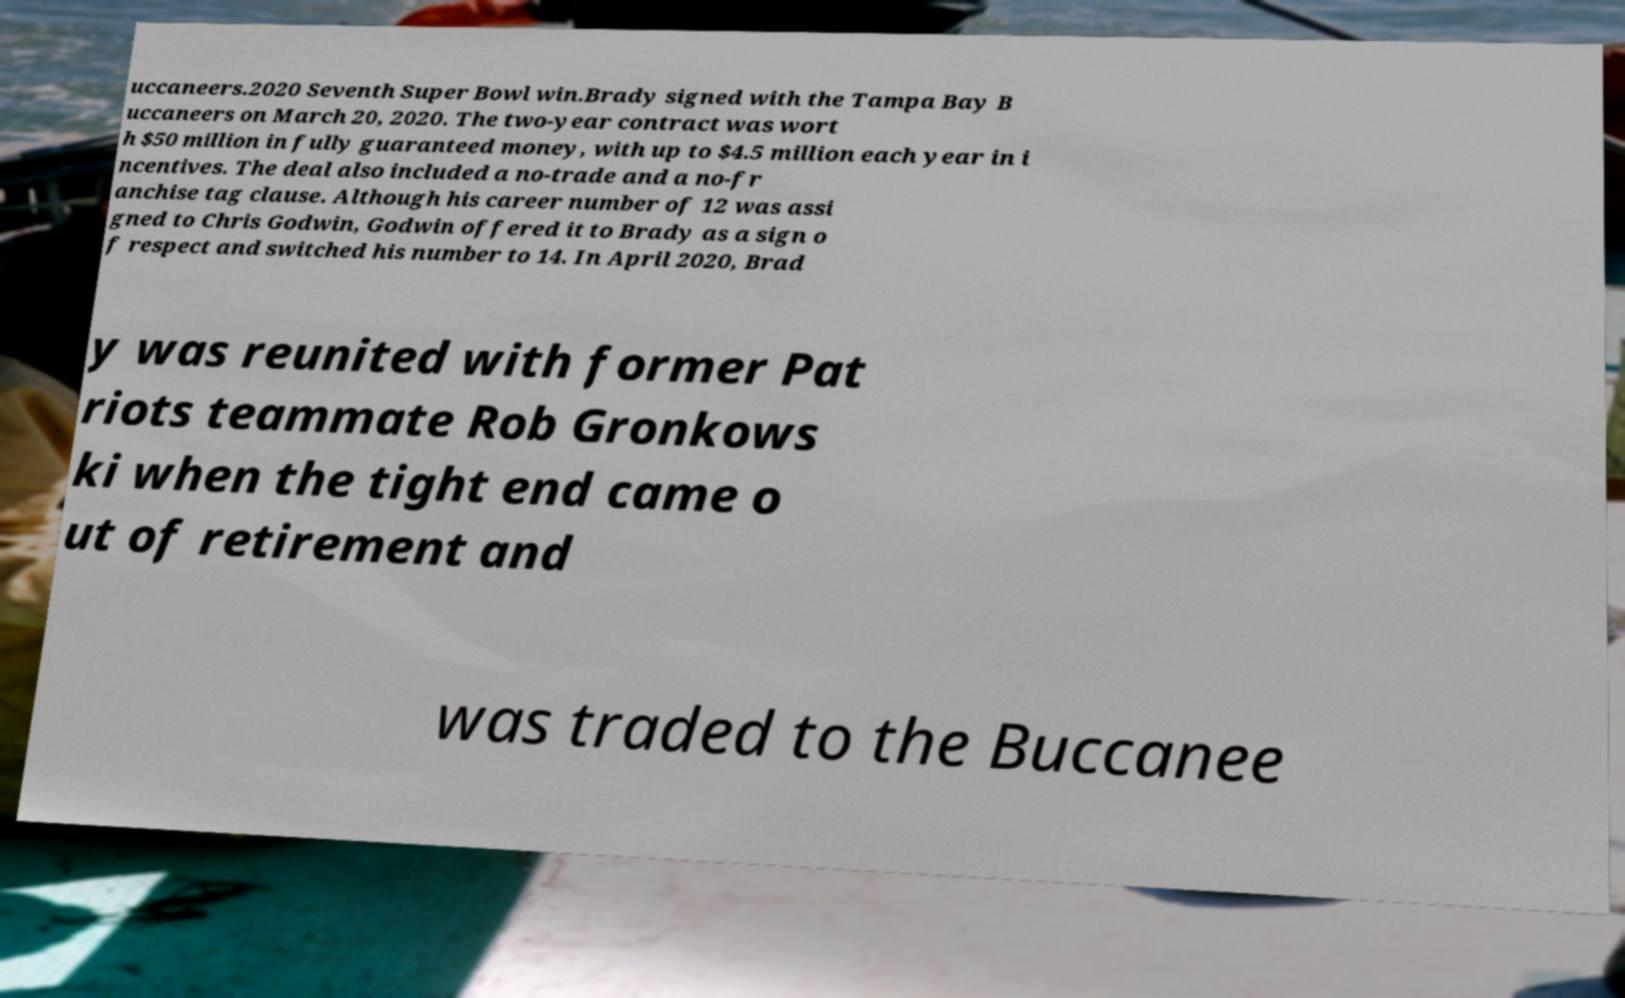There's text embedded in this image that I need extracted. Can you transcribe it verbatim? uccaneers.2020 Seventh Super Bowl win.Brady signed with the Tampa Bay B uccaneers on March 20, 2020. The two-year contract was wort h $50 million in fully guaranteed money, with up to $4.5 million each year in i ncentives. The deal also included a no-trade and a no-fr anchise tag clause. Although his career number of 12 was assi gned to Chris Godwin, Godwin offered it to Brady as a sign o f respect and switched his number to 14. In April 2020, Brad y was reunited with former Pat riots teammate Rob Gronkows ki when the tight end came o ut of retirement and was traded to the Buccanee 